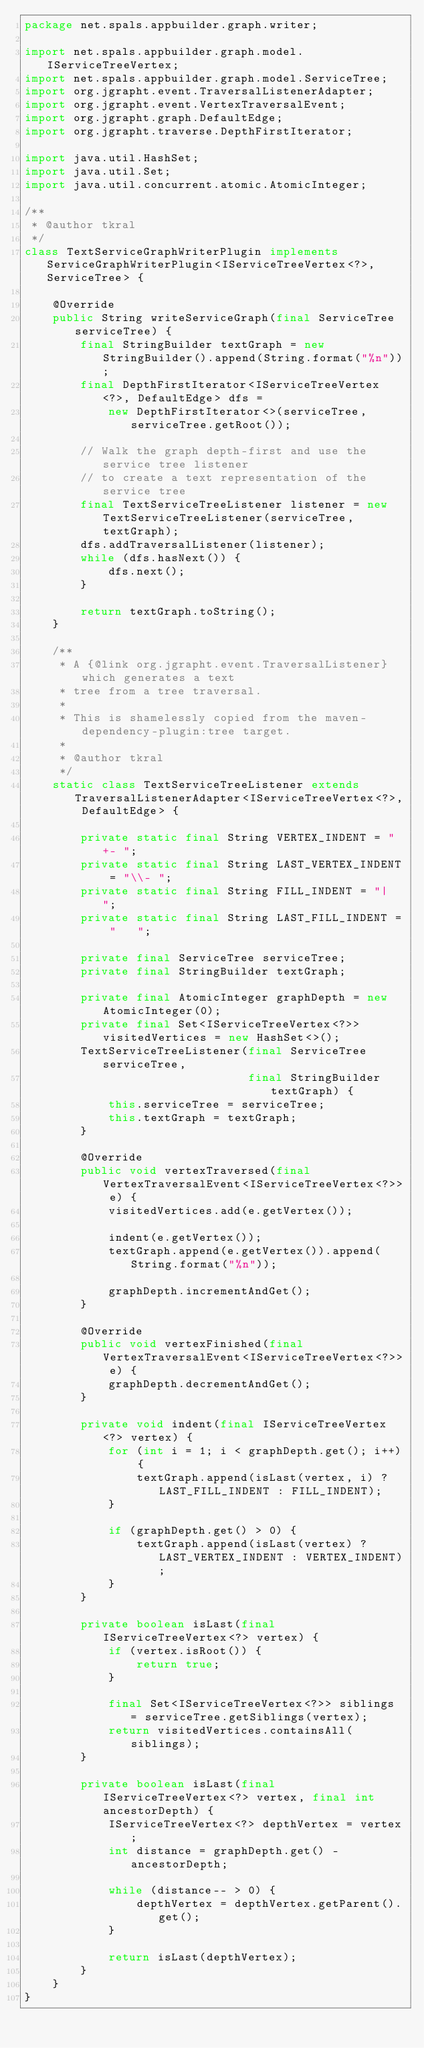<code> <loc_0><loc_0><loc_500><loc_500><_Java_>package net.spals.appbuilder.graph.writer;

import net.spals.appbuilder.graph.model.IServiceTreeVertex;
import net.spals.appbuilder.graph.model.ServiceTree;
import org.jgrapht.event.TraversalListenerAdapter;
import org.jgrapht.event.VertexTraversalEvent;
import org.jgrapht.graph.DefaultEdge;
import org.jgrapht.traverse.DepthFirstIterator;

import java.util.HashSet;
import java.util.Set;
import java.util.concurrent.atomic.AtomicInteger;

/**
 * @author tkral
 */
class TextServiceGraphWriterPlugin implements ServiceGraphWriterPlugin<IServiceTreeVertex<?>, ServiceTree> {

    @Override
    public String writeServiceGraph(final ServiceTree serviceTree) {
        final StringBuilder textGraph = new StringBuilder().append(String.format("%n"));
        final DepthFirstIterator<IServiceTreeVertex<?>, DefaultEdge> dfs =
            new DepthFirstIterator<>(serviceTree, serviceTree.getRoot());

        // Walk the graph depth-first and use the service tree listener
        // to create a text representation of the service tree
        final TextServiceTreeListener listener = new TextServiceTreeListener(serviceTree, textGraph);
        dfs.addTraversalListener(listener);
        while (dfs.hasNext()) {
            dfs.next();
        }

        return textGraph.toString();
    }

    /**
     * A {@link org.jgrapht.event.TraversalListener} which generates a text
     * tree from a tree traversal.
     *
     * This is shamelessly copied from the maven-dependency-plugin:tree target.
     *
     * @author tkral
     */
    static class TextServiceTreeListener extends TraversalListenerAdapter<IServiceTreeVertex<?>, DefaultEdge> {

        private static final String VERTEX_INDENT = "+- ";
        private static final String LAST_VERTEX_INDENT = "\\- ";
        private static final String FILL_INDENT = "|  ";
        private static final String LAST_FILL_INDENT = "   ";

        private final ServiceTree serviceTree;
        private final StringBuilder textGraph;

        private final AtomicInteger graphDepth = new AtomicInteger(0);
        private final Set<IServiceTreeVertex<?>> visitedVertices = new HashSet<>();
        TextServiceTreeListener(final ServiceTree serviceTree,
                                final StringBuilder textGraph) {
            this.serviceTree = serviceTree;
            this.textGraph = textGraph;
        }

        @Override
        public void vertexTraversed(final VertexTraversalEvent<IServiceTreeVertex<?>> e) {
            visitedVertices.add(e.getVertex());

            indent(e.getVertex());
            textGraph.append(e.getVertex()).append(String.format("%n"));

            graphDepth.incrementAndGet();
        }

        @Override
        public void vertexFinished(final VertexTraversalEvent<IServiceTreeVertex<?>> e) {
            graphDepth.decrementAndGet();
        }

        private void indent(final IServiceTreeVertex<?> vertex) {
            for (int i = 1; i < graphDepth.get(); i++) {
                textGraph.append(isLast(vertex, i) ? LAST_FILL_INDENT : FILL_INDENT);
            }

            if (graphDepth.get() > 0) {
                textGraph.append(isLast(vertex) ? LAST_VERTEX_INDENT : VERTEX_INDENT);
            }
        }

        private boolean isLast(final IServiceTreeVertex<?> vertex) {
            if (vertex.isRoot()) {
                return true;
            }

            final Set<IServiceTreeVertex<?>> siblings = serviceTree.getSiblings(vertex);
            return visitedVertices.containsAll(siblings);
        }

        private boolean isLast(final IServiceTreeVertex<?> vertex, final int ancestorDepth) {
            IServiceTreeVertex<?> depthVertex = vertex;
            int distance = graphDepth.get() - ancestorDepth;

            while (distance-- > 0) {
                depthVertex = depthVertex.getParent().get();
            }

            return isLast(depthVertex);
        }
    }
}
</code> 